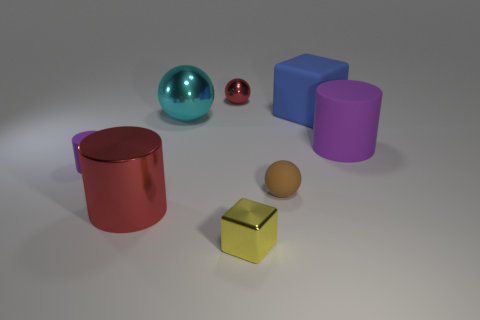Add 1 big green matte objects. How many objects exist? 9 Subtract all cubes. How many objects are left? 6 Add 2 large gray metallic cubes. How many large gray metallic cubes exist? 2 Subtract 1 yellow cubes. How many objects are left? 7 Subtract all tiny purple matte cubes. Subtract all large metal things. How many objects are left? 6 Add 7 big metallic cylinders. How many big metallic cylinders are left? 8 